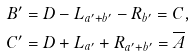<formula> <loc_0><loc_0><loc_500><loc_500>B ^ { \prime } & = D - L _ { a ^ { \prime } + b ^ { \prime } } - R _ { b ^ { \prime } } = C , \\ C ^ { \prime } & = D + L _ { a ^ { \prime } } + R _ { a ^ { \prime } + b ^ { \prime } } = \overline { A }</formula> 